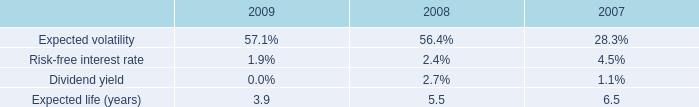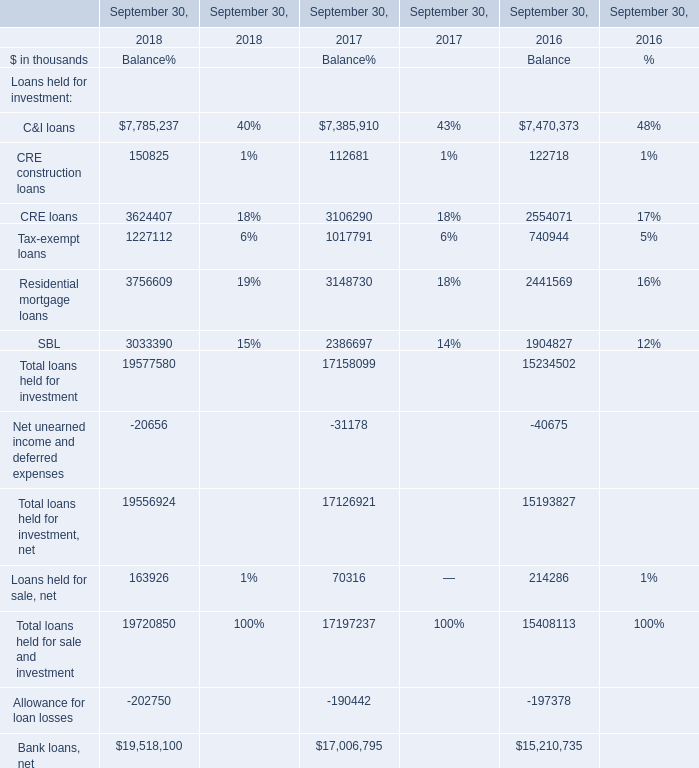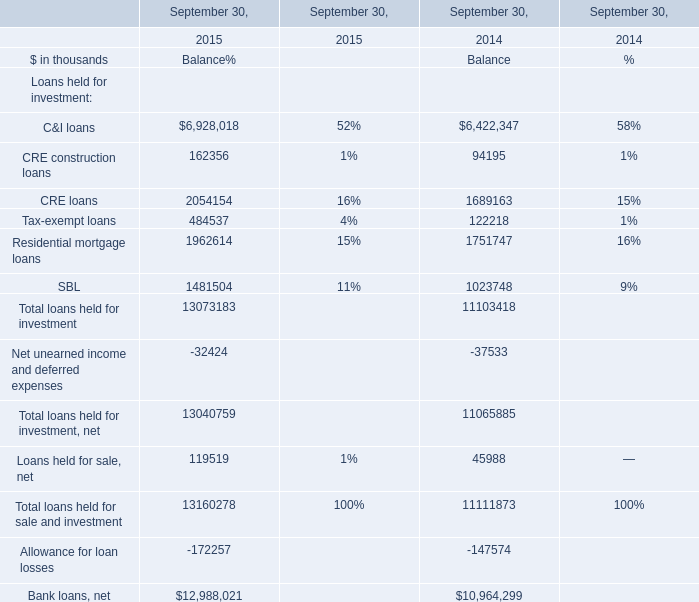Which year is Loans held for sale, net the least? 
Answer: 2017. 